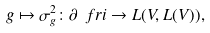Convert formula to latex. <formula><loc_0><loc_0><loc_500><loc_500>g \mapsto \sigma _ { g } ^ { 2 } \colon \partial \ f r i \to L ( V , L ( V ) ) ,</formula> 